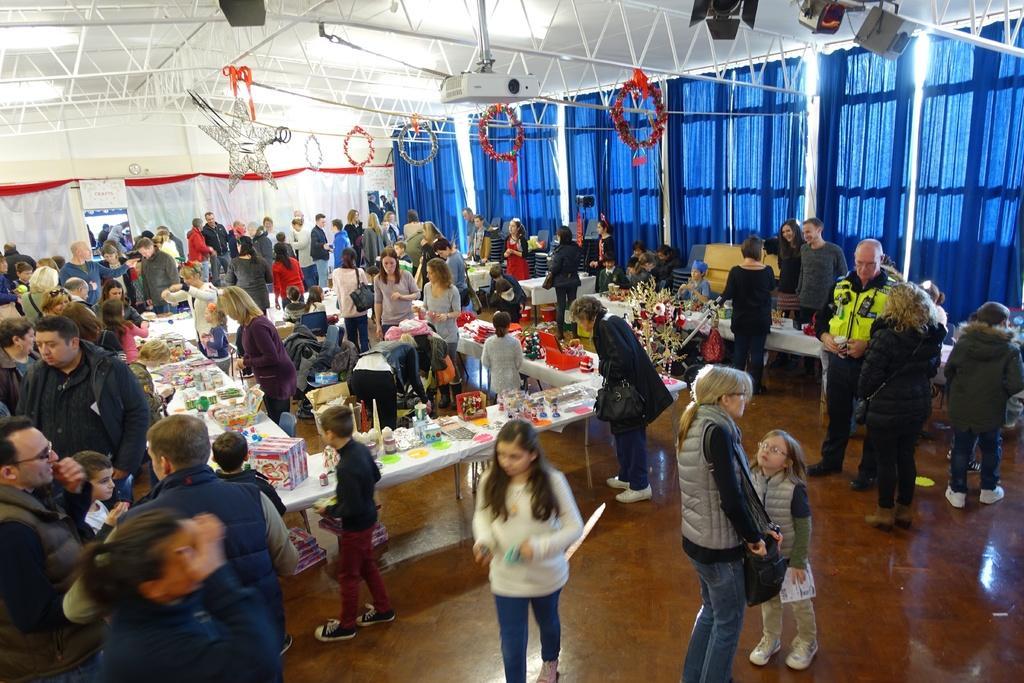How would you summarize this image in a sentence or two? It is a store, a group of people are walking and observing these things. At the top it's a projector. 